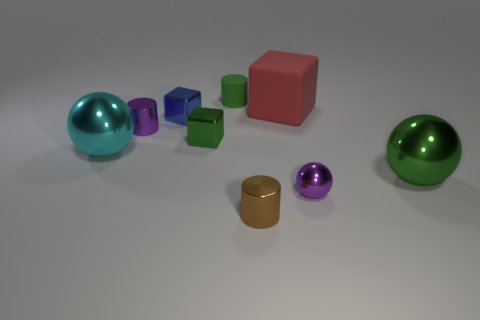Add 1 big cyan shiny objects. How many objects exist? 10 Subtract all cylinders. How many objects are left? 6 Subtract all shiny spheres. Subtract all green blocks. How many objects are left? 5 Add 3 small metallic cylinders. How many small metallic cylinders are left? 5 Add 9 large green spheres. How many large green spheres exist? 10 Subtract 1 blue cubes. How many objects are left? 8 